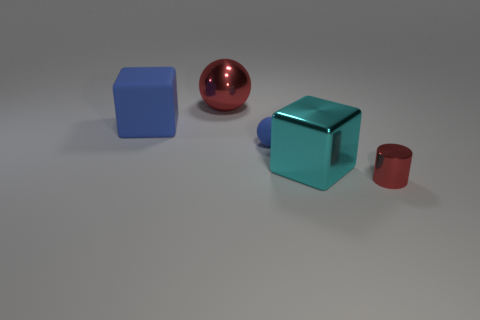There is a sphere in front of the big red thing behind the big rubber cube; what size is it?
Keep it short and to the point. Small. There is a object that is both in front of the large red shiny sphere and behind the small sphere; how big is it?
Offer a very short reply. Large. How many cyan shiny cubes are the same size as the red metal sphere?
Offer a terse response. 1. What number of matte objects are either blocks or blue objects?
Give a very brief answer. 2. There is a sphere that is the same color as the rubber block; what size is it?
Your answer should be very brief. Small. What material is the object that is to the left of the metallic thing that is behind the big cyan thing?
Provide a succinct answer. Rubber. What number of objects are either metallic cubes or red objects that are behind the blue matte sphere?
Provide a succinct answer. 2. There is a blue sphere that is the same material as the big blue object; what is its size?
Your answer should be very brief. Small. What number of yellow things are cylinders or small objects?
Your answer should be compact. 0. What shape is the metal thing that is the same color as the tiny shiny cylinder?
Give a very brief answer. Sphere. 